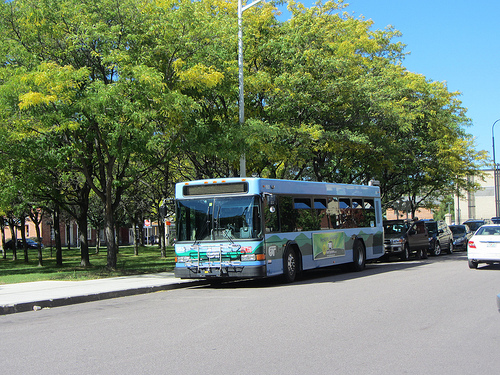Is the door open or closed? The door of the bus is open, allowing passengers to board or alight. 